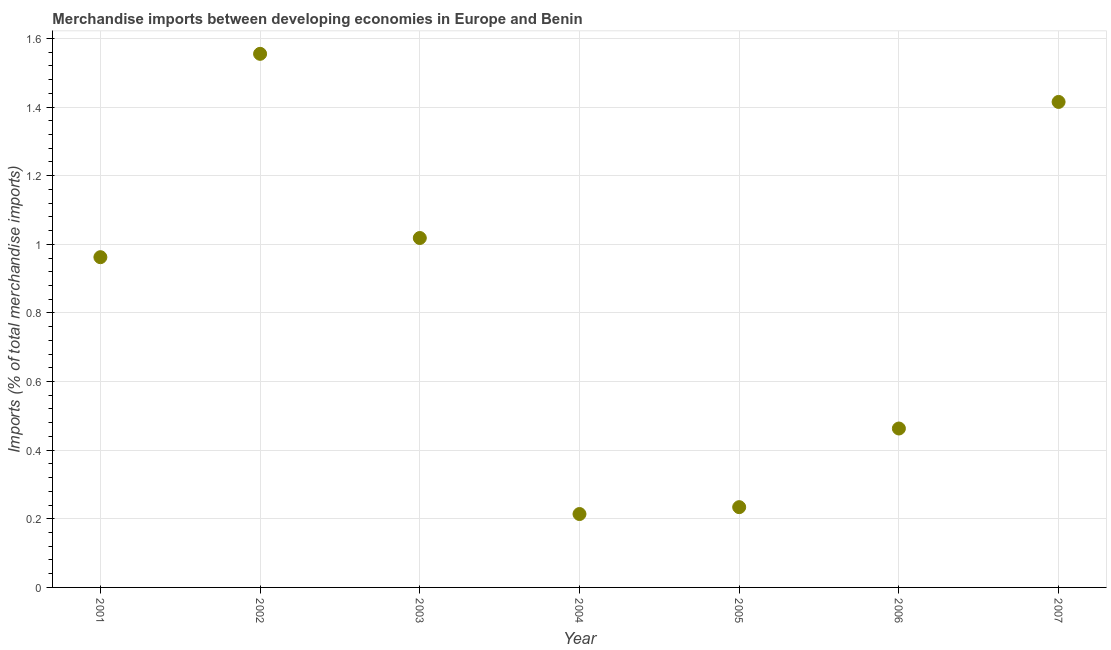What is the merchandise imports in 2001?
Offer a terse response. 0.96. Across all years, what is the maximum merchandise imports?
Provide a short and direct response. 1.56. Across all years, what is the minimum merchandise imports?
Your answer should be very brief. 0.21. In which year was the merchandise imports maximum?
Provide a short and direct response. 2002. What is the sum of the merchandise imports?
Your response must be concise. 5.86. What is the difference between the merchandise imports in 2002 and 2007?
Ensure brevity in your answer.  0.14. What is the average merchandise imports per year?
Offer a very short reply. 0.84. What is the median merchandise imports?
Keep it short and to the point. 0.96. What is the ratio of the merchandise imports in 2002 to that in 2005?
Your answer should be compact. 6.65. What is the difference between the highest and the second highest merchandise imports?
Offer a very short reply. 0.14. Is the sum of the merchandise imports in 2002 and 2003 greater than the maximum merchandise imports across all years?
Your answer should be very brief. Yes. What is the difference between the highest and the lowest merchandise imports?
Keep it short and to the point. 1.34. In how many years, is the merchandise imports greater than the average merchandise imports taken over all years?
Your answer should be compact. 4. How many years are there in the graph?
Keep it short and to the point. 7. Are the values on the major ticks of Y-axis written in scientific E-notation?
Make the answer very short. No. Does the graph contain any zero values?
Provide a short and direct response. No. Does the graph contain grids?
Provide a short and direct response. Yes. What is the title of the graph?
Your answer should be very brief. Merchandise imports between developing economies in Europe and Benin. What is the label or title of the Y-axis?
Your answer should be compact. Imports (% of total merchandise imports). What is the Imports (% of total merchandise imports) in 2001?
Provide a succinct answer. 0.96. What is the Imports (% of total merchandise imports) in 2002?
Provide a short and direct response. 1.56. What is the Imports (% of total merchandise imports) in 2003?
Offer a terse response. 1.02. What is the Imports (% of total merchandise imports) in 2004?
Make the answer very short. 0.21. What is the Imports (% of total merchandise imports) in 2005?
Offer a very short reply. 0.23. What is the Imports (% of total merchandise imports) in 2006?
Make the answer very short. 0.46. What is the Imports (% of total merchandise imports) in 2007?
Keep it short and to the point. 1.41. What is the difference between the Imports (% of total merchandise imports) in 2001 and 2002?
Make the answer very short. -0.59. What is the difference between the Imports (% of total merchandise imports) in 2001 and 2003?
Offer a very short reply. -0.06. What is the difference between the Imports (% of total merchandise imports) in 2001 and 2004?
Make the answer very short. 0.75. What is the difference between the Imports (% of total merchandise imports) in 2001 and 2005?
Your answer should be very brief. 0.73. What is the difference between the Imports (% of total merchandise imports) in 2001 and 2006?
Give a very brief answer. 0.5. What is the difference between the Imports (% of total merchandise imports) in 2001 and 2007?
Offer a very short reply. -0.45. What is the difference between the Imports (% of total merchandise imports) in 2002 and 2003?
Offer a terse response. 0.54. What is the difference between the Imports (% of total merchandise imports) in 2002 and 2004?
Ensure brevity in your answer.  1.34. What is the difference between the Imports (% of total merchandise imports) in 2002 and 2005?
Give a very brief answer. 1.32. What is the difference between the Imports (% of total merchandise imports) in 2002 and 2006?
Give a very brief answer. 1.09. What is the difference between the Imports (% of total merchandise imports) in 2002 and 2007?
Keep it short and to the point. 0.14. What is the difference between the Imports (% of total merchandise imports) in 2003 and 2004?
Keep it short and to the point. 0.8. What is the difference between the Imports (% of total merchandise imports) in 2003 and 2005?
Provide a succinct answer. 0.78. What is the difference between the Imports (% of total merchandise imports) in 2003 and 2006?
Give a very brief answer. 0.56. What is the difference between the Imports (% of total merchandise imports) in 2003 and 2007?
Offer a terse response. -0.4. What is the difference between the Imports (% of total merchandise imports) in 2004 and 2005?
Keep it short and to the point. -0.02. What is the difference between the Imports (% of total merchandise imports) in 2004 and 2006?
Keep it short and to the point. -0.25. What is the difference between the Imports (% of total merchandise imports) in 2004 and 2007?
Ensure brevity in your answer.  -1.2. What is the difference between the Imports (% of total merchandise imports) in 2005 and 2006?
Offer a very short reply. -0.23. What is the difference between the Imports (% of total merchandise imports) in 2005 and 2007?
Provide a short and direct response. -1.18. What is the difference between the Imports (% of total merchandise imports) in 2006 and 2007?
Provide a short and direct response. -0.95. What is the ratio of the Imports (% of total merchandise imports) in 2001 to that in 2002?
Your answer should be compact. 0.62. What is the ratio of the Imports (% of total merchandise imports) in 2001 to that in 2003?
Offer a very short reply. 0.94. What is the ratio of the Imports (% of total merchandise imports) in 2001 to that in 2004?
Give a very brief answer. 4.5. What is the ratio of the Imports (% of total merchandise imports) in 2001 to that in 2005?
Your response must be concise. 4.11. What is the ratio of the Imports (% of total merchandise imports) in 2001 to that in 2006?
Provide a short and direct response. 2.08. What is the ratio of the Imports (% of total merchandise imports) in 2001 to that in 2007?
Make the answer very short. 0.68. What is the ratio of the Imports (% of total merchandise imports) in 2002 to that in 2003?
Your response must be concise. 1.53. What is the ratio of the Imports (% of total merchandise imports) in 2002 to that in 2004?
Offer a very short reply. 7.27. What is the ratio of the Imports (% of total merchandise imports) in 2002 to that in 2005?
Make the answer very short. 6.65. What is the ratio of the Imports (% of total merchandise imports) in 2002 to that in 2006?
Provide a succinct answer. 3.36. What is the ratio of the Imports (% of total merchandise imports) in 2002 to that in 2007?
Keep it short and to the point. 1.1. What is the ratio of the Imports (% of total merchandise imports) in 2003 to that in 2004?
Provide a short and direct response. 4.76. What is the ratio of the Imports (% of total merchandise imports) in 2003 to that in 2005?
Your answer should be compact. 4.35. What is the ratio of the Imports (% of total merchandise imports) in 2003 to that in 2006?
Offer a very short reply. 2.2. What is the ratio of the Imports (% of total merchandise imports) in 2003 to that in 2007?
Your response must be concise. 0.72. What is the ratio of the Imports (% of total merchandise imports) in 2004 to that in 2005?
Offer a terse response. 0.91. What is the ratio of the Imports (% of total merchandise imports) in 2004 to that in 2006?
Keep it short and to the point. 0.46. What is the ratio of the Imports (% of total merchandise imports) in 2004 to that in 2007?
Provide a succinct answer. 0.15. What is the ratio of the Imports (% of total merchandise imports) in 2005 to that in 2006?
Give a very brief answer. 0.51. What is the ratio of the Imports (% of total merchandise imports) in 2005 to that in 2007?
Your answer should be compact. 0.17. What is the ratio of the Imports (% of total merchandise imports) in 2006 to that in 2007?
Keep it short and to the point. 0.33. 